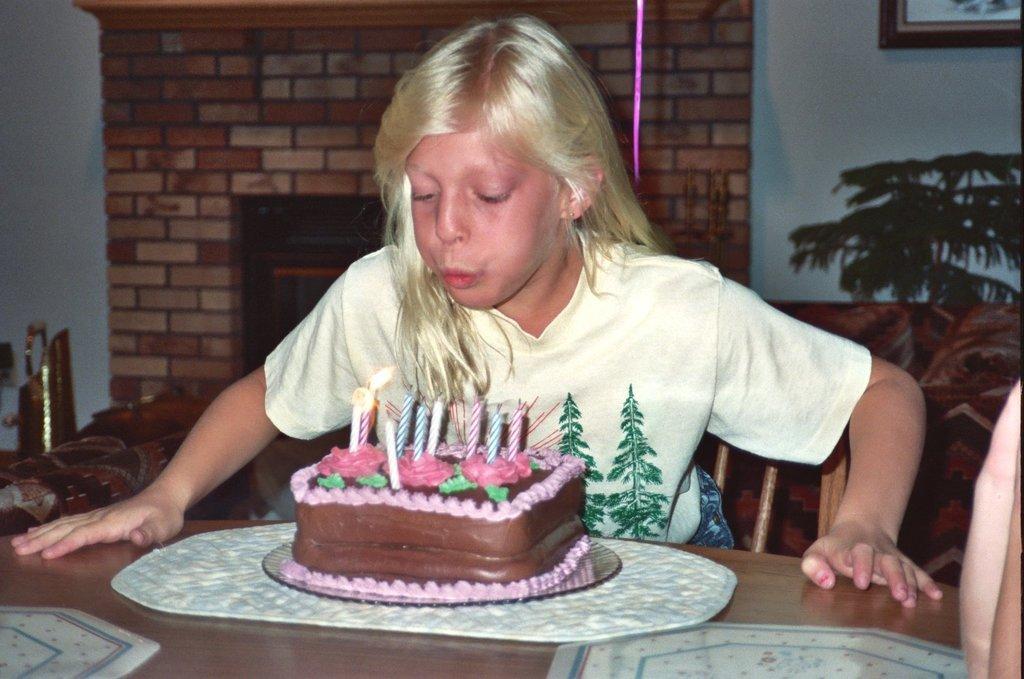Can you describe this image briefly? There is a girl sitting in the center of the image in front of a table, there is a cake on the table and a person on the right side. There is a portrait, plant, wall and other objects in the background area. 